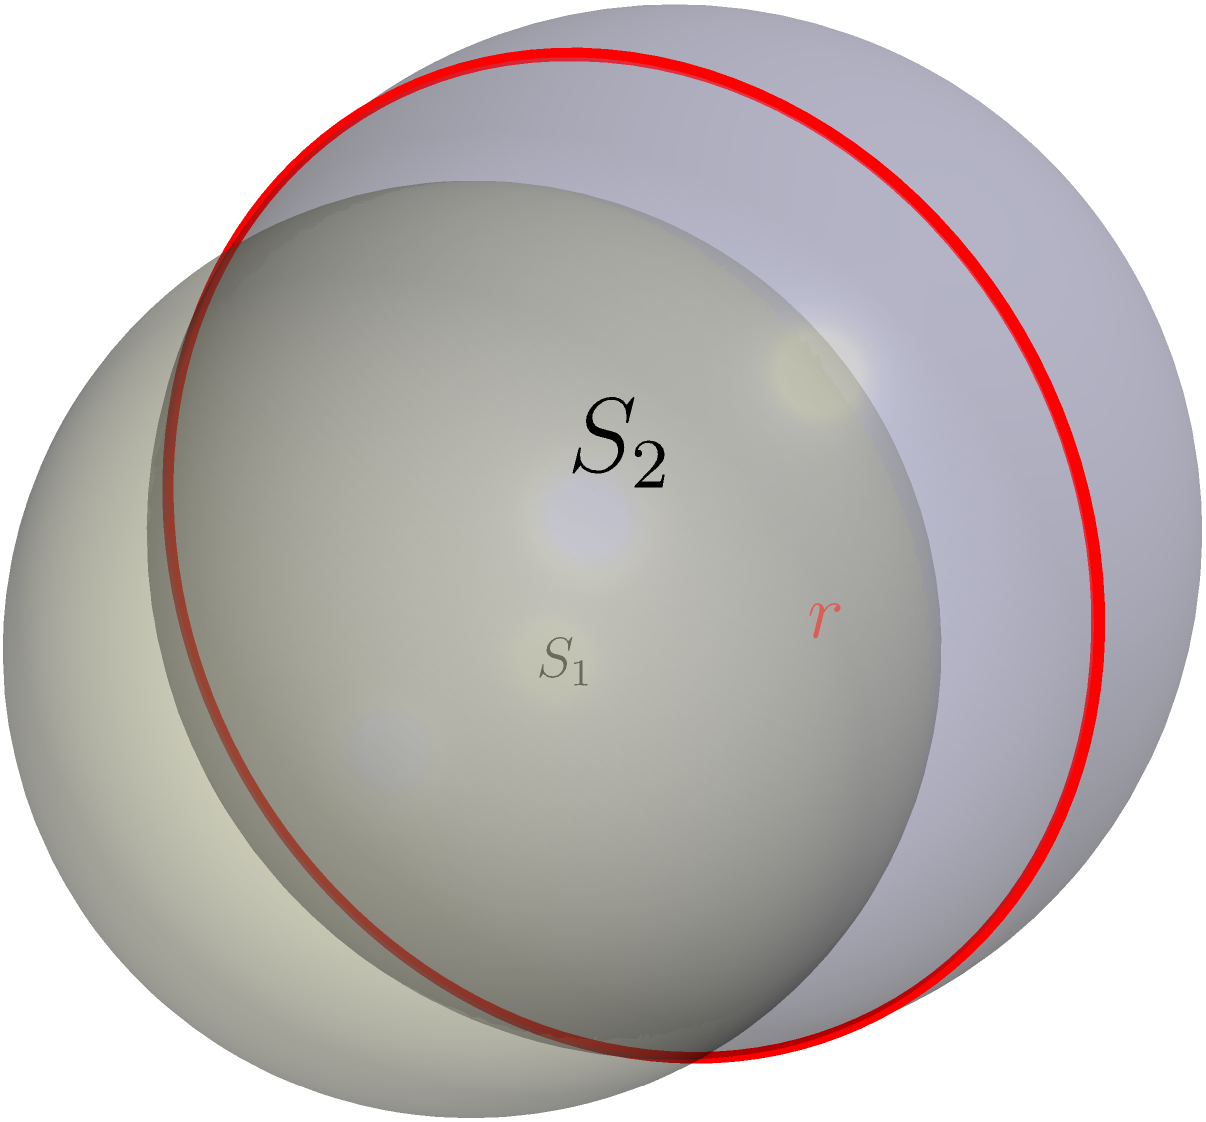In the diagram, two spheres $S_1$ and $S_2$ with radii $R_1 = 2$ and $R_2 = 1.5$ respectively, intersect. The center of $S_2$ is located 1.5 units to the right of $S_1$'s center along the x-axis. Calculate the radius $r$ of the circular intersection between the two spheres. How might this 3D concept be challenging to convey effectively in a traditional book format? To solve this problem, we'll follow these steps:

1) First, we need to understand that the intersection of two spheres forms a circle.

2) The center of this intersection circle lies on the line connecting the centers of the two spheres.

3) Let's consider the right triangle formed by:
   - The center of $S_1$
   - The center of the intersection circle
   - The edge of the intersection circle

4) In this triangle:
   - The hypotenuse is $R_1 = 2$ (radius of $S_1$)
   - One leg is the distance from $S_1$'s center to the intersection circle's center, which is half the distance between the sphere centers: $1.5/2 = 0.75$
   - The other leg is $r$, the radius we're trying to find

5) We can use the Pythagorean theorem:

   $$R_1^2 = 0.75^2 + r^2$$

6) Substituting the known values:

   $$2^2 = 0.75^2 + r^2$$
   $$4 = 0.5625 + r^2$$

7) Solving for $r$:

   $$r^2 = 4 - 0.5625 = 3.4375$$
   $$r = \sqrt{3.4375} \approx 1.8541$$

8) Therefore, the radius of the intersection circle is approximately 1.8541 units.

Challenges in conveying this 3D concept in a traditional book format:
- Difficulty in representing depth and perspective on a 2D page
- Limited ability to show multiple viewpoints or cross-sections
- Inability for readers to manipulate or rotate the image
- Challenges in clearly depicting hidden or partially obscured elements
- Reliance on readers' spatial reasoning skills to interpret 2D representations of 3D objects
Answer: $r \approx 1.8541$ units. Challenges: depth perception, limited viewpoints, lack of interactivity, hidden elements, spatial reasoning demands. 